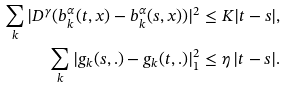Convert formula to latex. <formula><loc_0><loc_0><loc_500><loc_500>\sum _ { k } | D ^ { \gamma } ( b ^ { \alpha } _ { k } ( t , x ) - b ^ { \alpha } _ { k } ( s , x ) ) | ^ { 2 } & \leq K | t - s | , \\ \sum _ { k } | g _ { k } ( s , . ) - g _ { k } ( t , . ) | _ { 1 } ^ { 2 } & \leq \eta \, | t - s | .</formula> 